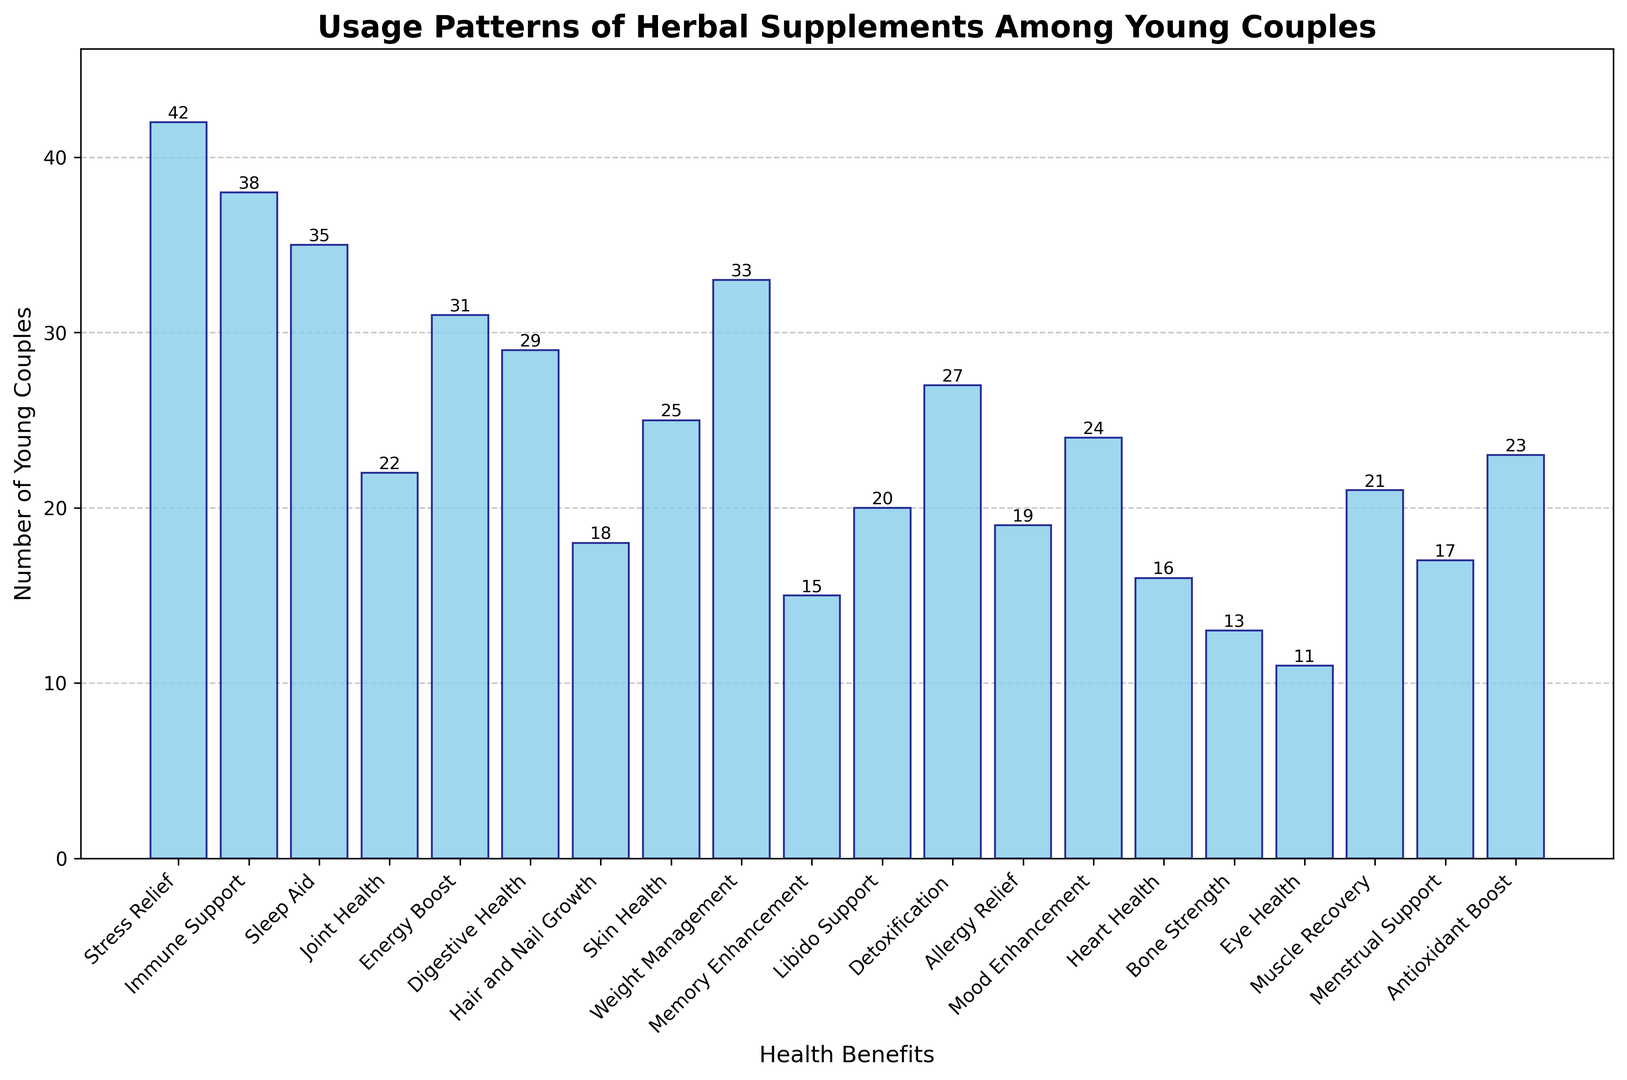Which health benefit has the highest number of young couples using herbal supplements? The bar corresponding to "Stress Relief" is the tallest among all bars in the histogram, indicating it has the highest count.
Answer: Stress Relief What is the total number of young couples using herbal supplements for "Weight Management" and "Digestive Health"? Locate the bars for "Weight Management" and "Digestive Health". The counts are 33 and 29 respectively. Sum them up: 33 + 29 = 62.
Answer: 62 Are there more young couples using supplements for "Immune Support" or "Sleep Aid"? Compare the heights of the bars for "Immune Support" and "Sleep Aid". The bar for "Immune Support" is taller with a count of 38, while "Sleep Aid" is 35.
Answer: Immune Support What's the average number of couples using supplements for "Heart Health", "Bone Strength", and "Eye Health"? Find the bars for "Heart Health", "Bone Strength", and "Eye Health". Their counts are 16, 13, and 11 respectively. Average them: (16 + 13 + 11)/3 = 40/3 ≈ 13.33.
Answer: 13.33 How many more young couples use supplements for "Libido Support" compared to "Hair and Nail Growth"? Locate the bars for "Libido Support" and "Hair and Nail Growth". Their counts are 20 and 18 respectively. Subtract the counts: 20 - 18 = 2.
Answer: 2 Which three health benefits have the lowest number of young couples using supplements? Look at the shortest bars in the histogram. The three shortest are for "Eye Health" (11), "Bone Strength" (13), and "Memory Enhancement" (15).
Answer: Eye Health, Bone Strength, Memory Enhancement Is the number of couples using supplements for "Energy Boost" greater than for "Detoxification"? Compare the height of the bars for "Energy Boost" and "Detoxification". The bar for "Energy Boost" (31) is taller than "Detoxification" (27).
Answer: Yes What is the difference between the number of couples using supplements for "Mood Enhancement" and "Allergy Relief"? Locate the bars for "Mood Enhancement" and "Allergy Relief". The counts are 24 and 19 respectively. Subtract the counts: 24 - 19 = 5.
Answer: 5 What's the combined number of young couples using supplements for "Joint Health" and "Muscle Recovery"? Locate the bars for "Joint Health" and "Muscle Recovery". The counts are 22 and 21 respectively. Sum them up: 22 + 21 = 43.
Answer: 43 